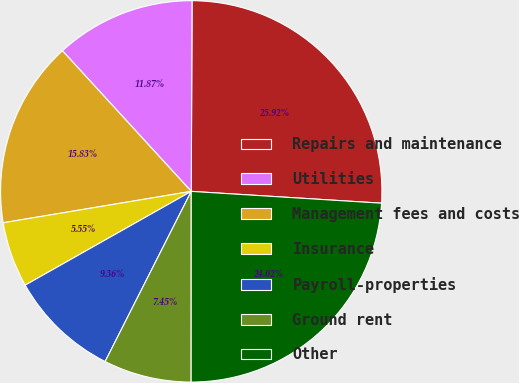Convert chart to OTSL. <chart><loc_0><loc_0><loc_500><loc_500><pie_chart><fcel>Repairs and maintenance<fcel>Utilities<fcel>Management fees and costs<fcel>Insurance<fcel>Payroll-properties<fcel>Ground rent<fcel>Other<nl><fcel>25.92%<fcel>11.87%<fcel>15.83%<fcel>5.55%<fcel>9.36%<fcel>7.45%<fcel>24.02%<nl></chart> 